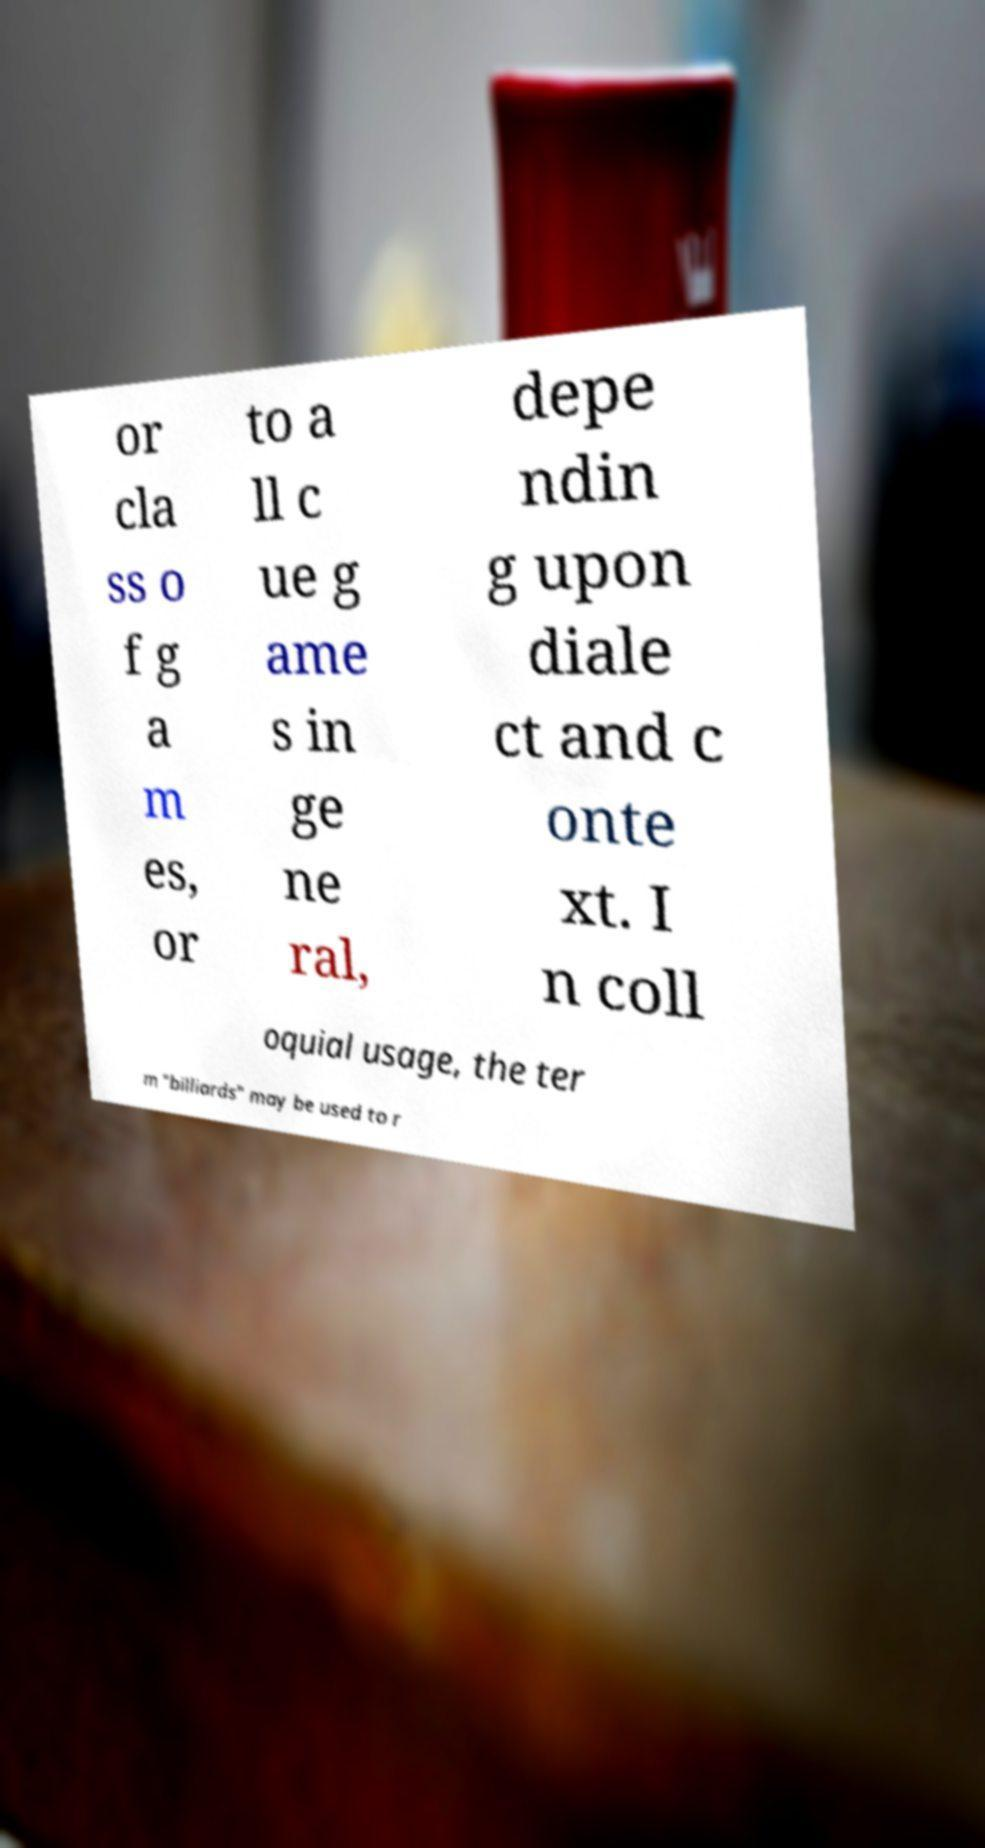Please identify and transcribe the text found in this image. or cla ss o f g a m es, or to a ll c ue g ame s in ge ne ral, depe ndin g upon diale ct and c onte xt. I n coll oquial usage, the ter m "billiards" may be used to r 